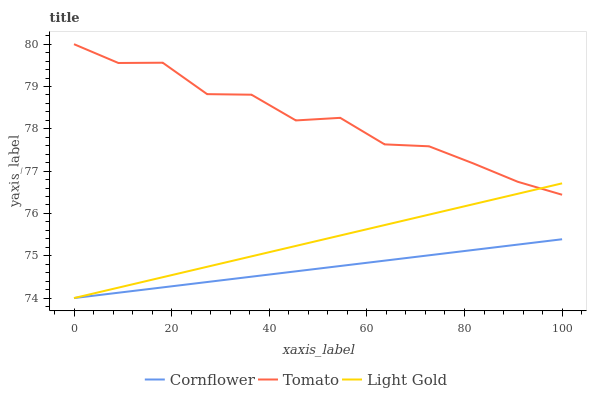Does Cornflower have the minimum area under the curve?
Answer yes or no. Yes. Does Tomato have the maximum area under the curve?
Answer yes or no. Yes. Does Light Gold have the minimum area under the curve?
Answer yes or no. No. Does Light Gold have the maximum area under the curve?
Answer yes or no. No. Is Cornflower the smoothest?
Answer yes or no. Yes. Is Tomato the roughest?
Answer yes or no. Yes. Is Light Gold the smoothest?
Answer yes or no. No. Is Light Gold the roughest?
Answer yes or no. No. Does Cornflower have the lowest value?
Answer yes or no. Yes. Does Tomato have the highest value?
Answer yes or no. Yes. Does Light Gold have the highest value?
Answer yes or no. No. Is Cornflower less than Tomato?
Answer yes or no. Yes. Is Tomato greater than Cornflower?
Answer yes or no. Yes. Does Cornflower intersect Light Gold?
Answer yes or no. Yes. Is Cornflower less than Light Gold?
Answer yes or no. No. Is Cornflower greater than Light Gold?
Answer yes or no. No. Does Cornflower intersect Tomato?
Answer yes or no. No. 